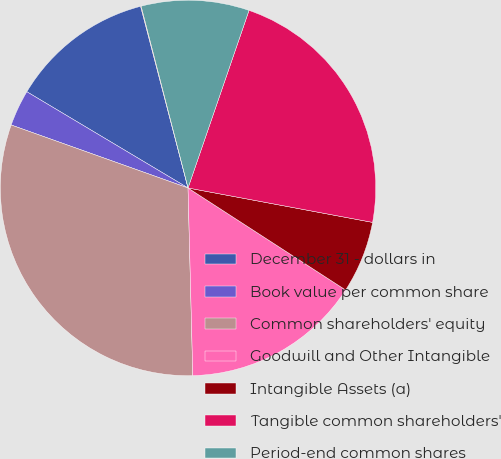Convert chart. <chart><loc_0><loc_0><loc_500><loc_500><pie_chart><fcel>December 31 - dollars in<fcel>Book value per common share<fcel>Common shareholders' equity<fcel>Goodwill and Other Intangible<fcel>Intangible Assets (a)<fcel>Tangible common shareholders'<fcel>Period-end common shares<fcel>Tangible book value per common<nl><fcel>12.37%<fcel>3.12%<fcel>30.85%<fcel>15.45%<fcel>6.21%<fcel>22.67%<fcel>9.29%<fcel>0.04%<nl></chart> 